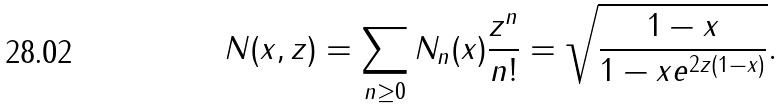Convert formula to latex. <formula><loc_0><loc_0><loc_500><loc_500>N ( x , z ) = \sum _ { n \geq 0 } N _ { n } ( x ) \frac { z ^ { n } } { n ! } = \sqrt { \frac { 1 - x } { 1 - x e ^ { 2 z ( 1 - x ) } } } .</formula> 